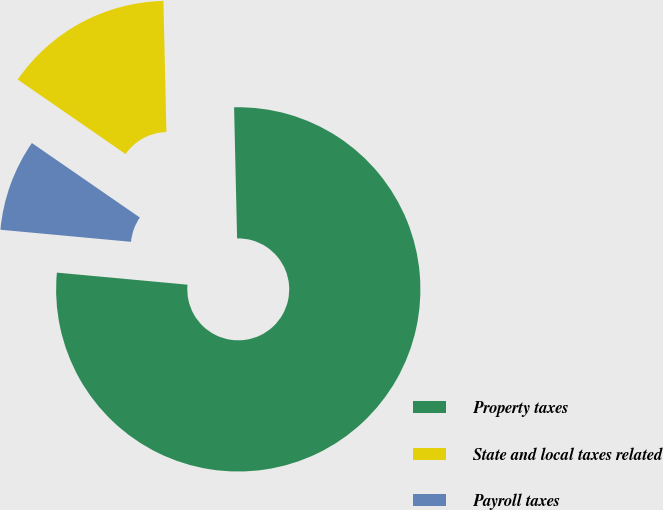Convert chart. <chart><loc_0><loc_0><loc_500><loc_500><pie_chart><fcel>Property taxes<fcel>State and local taxes related<fcel>Payroll taxes<nl><fcel>76.83%<fcel>15.02%<fcel>8.15%<nl></chart> 